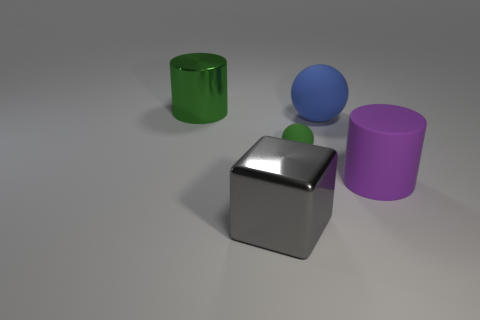There is a large cylinder that is the same color as the tiny rubber ball; what is it made of?
Your answer should be very brief. Metal. Is there any other thing that has the same shape as the big gray object?
Offer a terse response. No. There is a large cylinder behind the cylinder in front of the metallic thing behind the large gray shiny thing; what color is it?
Give a very brief answer. Green. What number of large objects are either metallic blocks or rubber cylinders?
Your response must be concise. 2. Are there an equal number of gray things that are in front of the big purple rubber object and large green objects?
Make the answer very short. Yes. There is a big green shiny cylinder; are there any gray shiny cubes in front of it?
Your response must be concise. Yes. What number of matte objects are either large spheres or cylinders?
Give a very brief answer. 2. There is a tiny green thing; what number of big spheres are behind it?
Ensure brevity in your answer.  1. Are there any blocks that have the same size as the purple matte thing?
Give a very brief answer. Yes. Is there a big metal object of the same color as the tiny rubber sphere?
Your answer should be compact. Yes. 